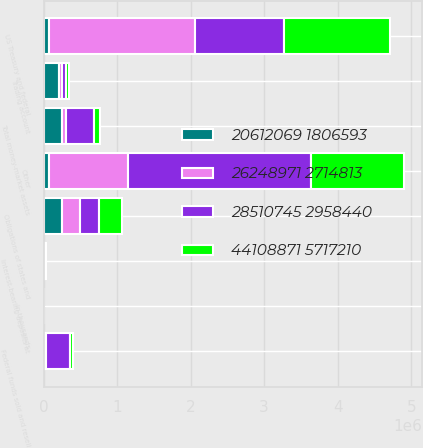<chart> <loc_0><loc_0><loc_500><loc_500><stacked_bar_chart><ecel><fcel>In thousands<fcel>Interest-bearing deposits at<fcel>Federal funds sold and resell<fcel>Trading account<fcel>Total money-market assets<fcel>US Treasury and federal<fcel>Obligations of states and<fcel>Other<nl><fcel>20612069 1806593<fcel>2003<fcel>13194<fcel>22288<fcel>214833<fcel>250315<fcel>71075<fcel>249193<fcel>71075<nl><fcel>28510745 2958440<fcel>2002<fcel>7856<fcel>320359<fcel>51628<fcel>379843<fcel>1.20918e+06<fcel>256023<fcel>2.48995e+06<nl><fcel>44108871 5717210<fcel>2001<fcel>4341<fcel>41086<fcel>38929<fcel>84356<fcel>1.4484e+06<fcel>306768<fcel>1.26897e+06<nl><fcel>26248971 2714813<fcel>2000<fcel>3102<fcel>17261<fcel>37431<fcel>57794<fcel>1.98435e+06<fcel>249425<fcel>1.07608e+06<nl></chart> 